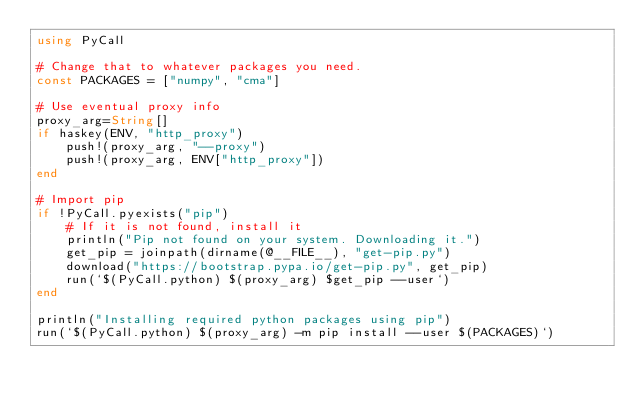<code> <loc_0><loc_0><loc_500><loc_500><_Julia_>using PyCall

# Change that to whatever packages you need.
const PACKAGES = ["numpy", "cma"]

# Use eventual proxy info
proxy_arg=String[]
if haskey(ENV, "http_proxy")
    push!(proxy_arg, "--proxy")
    push!(proxy_arg, ENV["http_proxy"])
end

# Import pip
if !PyCall.pyexists("pip")
    # If it is not found, install it
    println("Pip not found on your system. Downloading it.")
    get_pip = joinpath(dirname(@__FILE__), "get-pip.py")
    download("https://bootstrap.pypa.io/get-pip.py", get_pip)
    run(`$(PyCall.python) $(proxy_arg) $get_pip --user`)
end

println("Installing required python packages using pip")
run(`$(PyCall.python) $(proxy_arg) -m pip install --user $(PACKAGES)`)
</code> 